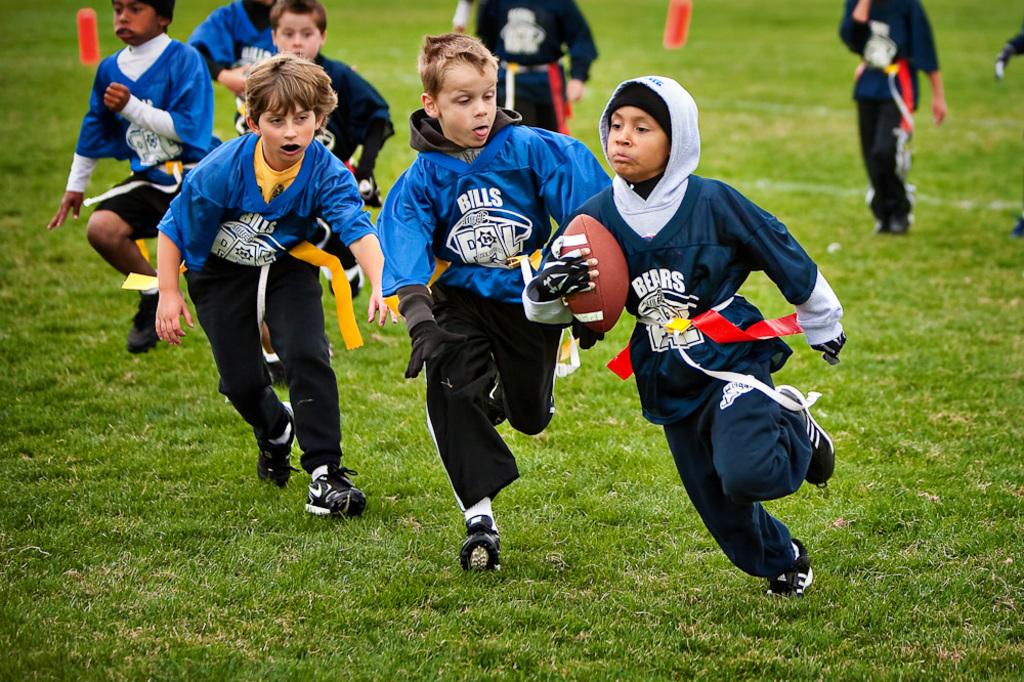What team is the boy who's carrying the football on?
Make the answer very short. Bears. What team name is on the blue jerseys?
Provide a short and direct response. Bills. 